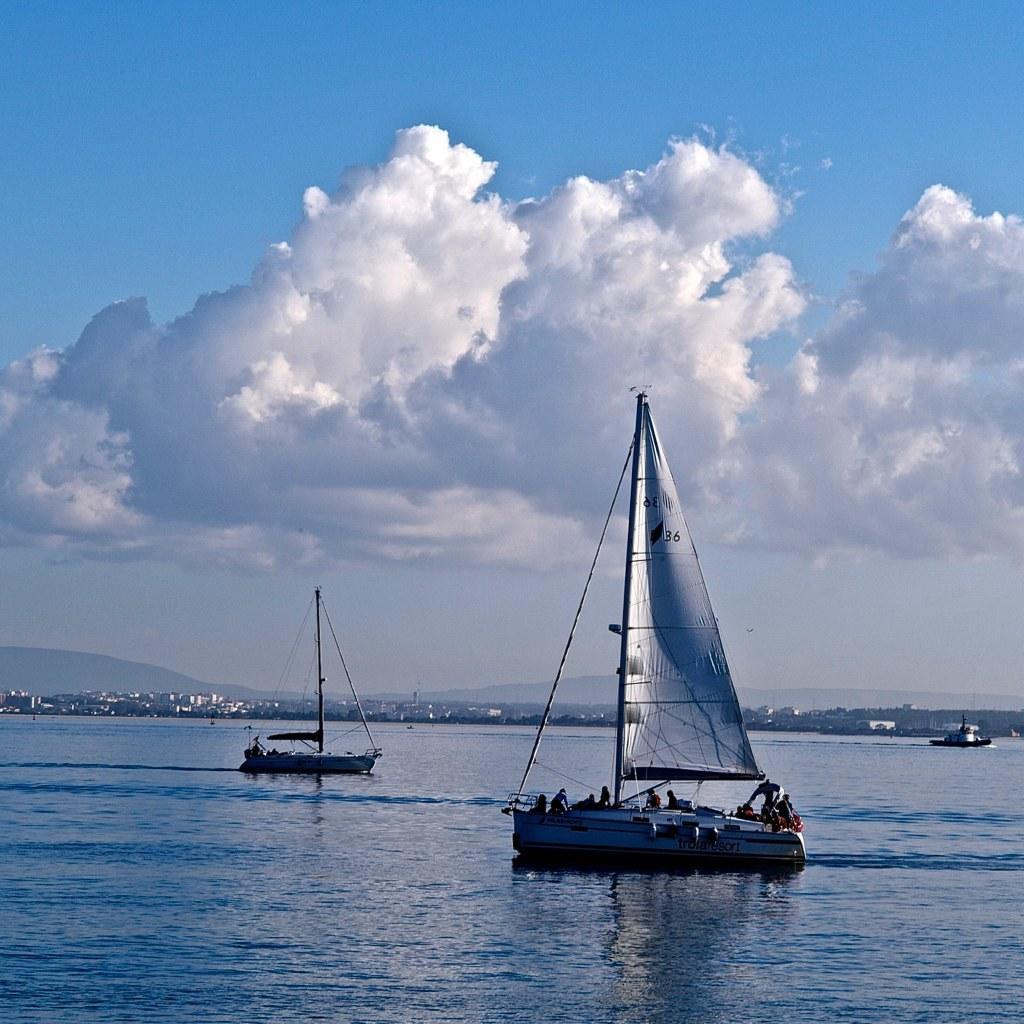Please provide a concise description of this image. In this picture we can see boats on water, buildings, mountains and in the background we can the sky with clouds. 